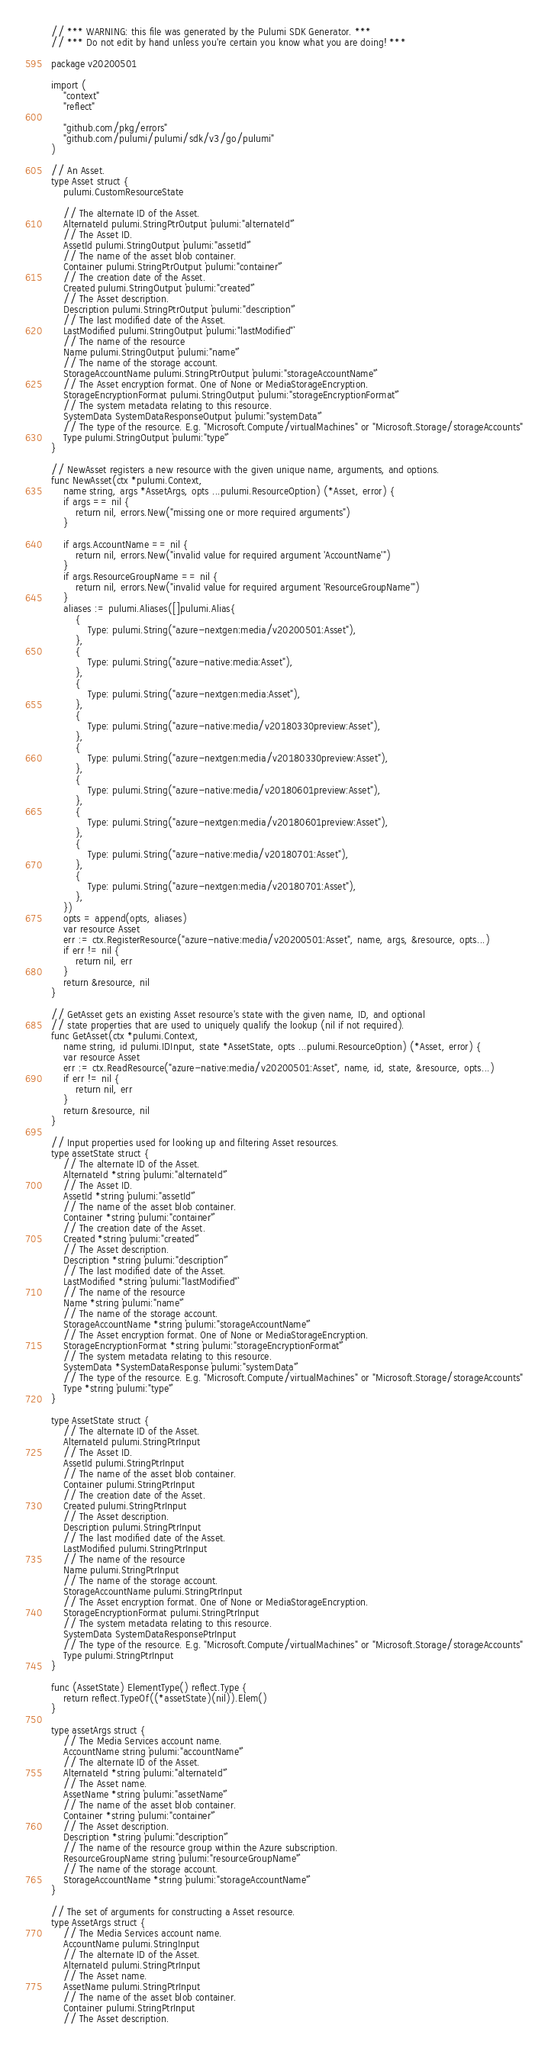Convert code to text. <code><loc_0><loc_0><loc_500><loc_500><_Go_>// *** WARNING: this file was generated by the Pulumi SDK Generator. ***
// *** Do not edit by hand unless you're certain you know what you are doing! ***

package v20200501

import (
	"context"
	"reflect"

	"github.com/pkg/errors"
	"github.com/pulumi/pulumi/sdk/v3/go/pulumi"
)

// An Asset.
type Asset struct {
	pulumi.CustomResourceState

	// The alternate ID of the Asset.
	AlternateId pulumi.StringPtrOutput `pulumi:"alternateId"`
	// The Asset ID.
	AssetId pulumi.StringOutput `pulumi:"assetId"`
	// The name of the asset blob container.
	Container pulumi.StringPtrOutput `pulumi:"container"`
	// The creation date of the Asset.
	Created pulumi.StringOutput `pulumi:"created"`
	// The Asset description.
	Description pulumi.StringPtrOutput `pulumi:"description"`
	// The last modified date of the Asset.
	LastModified pulumi.StringOutput `pulumi:"lastModified"`
	// The name of the resource
	Name pulumi.StringOutput `pulumi:"name"`
	// The name of the storage account.
	StorageAccountName pulumi.StringPtrOutput `pulumi:"storageAccountName"`
	// The Asset encryption format. One of None or MediaStorageEncryption.
	StorageEncryptionFormat pulumi.StringOutput `pulumi:"storageEncryptionFormat"`
	// The system metadata relating to this resource.
	SystemData SystemDataResponseOutput `pulumi:"systemData"`
	// The type of the resource. E.g. "Microsoft.Compute/virtualMachines" or "Microsoft.Storage/storageAccounts"
	Type pulumi.StringOutput `pulumi:"type"`
}

// NewAsset registers a new resource with the given unique name, arguments, and options.
func NewAsset(ctx *pulumi.Context,
	name string, args *AssetArgs, opts ...pulumi.ResourceOption) (*Asset, error) {
	if args == nil {
		return nil, errors.New("missing one or more required arguments")
	}

	if args.AccountName == nil {
		return nil, errors.New("invalid value for required argument 'AccountName'")
	}
	if args.ResourceGroupName == nil {
		return nil, errors.New("invalid value for required argument 'ResourceGroupName'")
	}
	aliases := pulumi.Aliases([]pulumi.Alias{
		{
			Type: pulumi.String("azure-nextgen:media/v20200501:Asset"),
		},
		{
			Type: pulumi.String("azure-native:media:Asset"),
		},
		{
			Type: pulumi.String("azure-nextgen:media:Asset"),
		},
		{
			Type: pulumi.String("azure-native:media/v20180330preview:Asset"),
		},
		{
			Type: pulumi.String("azure-nextgen:media/v20180330preview:Asset"),
		},
		{
			Type: pulumi.String("azure-native:media/v20180601preview:Asset"),
		},
		{
			Type: pulumi.String("azure-nextgen:media/v20180601preview:Asset"),
		},
		{
			Type: pulumi.String("azure-native:media/v20180701:Asset"),
		},
		{
			Type: pulumi.String("azure-nextgen:media/v20180701:Asset"),
		},
	})
	opts = append(opts, aliases)
	var resource Asset
	err := ctx.RegisterResource("azure-native:media/v20200501:Asset", name, args, &resource, opts...)
	if err != nil {
		return nil, err
	}
	return &resource, nil
}

// GetAsset gets an existing Asset resource's state with the given name, ID, and optional
// state properties that are used to uniquely qualify the lookup (nil if not required).
func GetAsset(ctx *pulumi.Context,
	name string, id pulumi.IDInput, state *AssetState, opts ...pulumi.ResourceOption) (*Asset, error) {
	var resource Asset
	err := ctx.ReadResource("azure-native:media/v20200501:Asset", name, id, state, &resource, opts...)
	if err != nil {
		return nil, err
	}
	return &resource, nil
}

// Input properties used for looking up and filtering Asset resources.
type assetState struct {
	// The alternate ID of the Asset.
	AlternateId *string `pulumi:"alternateId"`
	// The Asset ID.
	AssetId *string `pulumi:"assetId"`
	// The name of the asset blob container.
	Container *string `pulumi:"container"`
	// The creation date of the Asset.
	Created *string `pulumi:"created"`
	// The Asset description.
	Description *string `pulumi:"description"`
	// The last modified date of the Asset.
	LastModified *string `pulumi:"lastModified"`
	// The name of the resource
	Name *string `pulumi:"name"`
	// The name of the storage account.
	StorageAccountName *string `pulumi:"storageAccountName"`
	// The Asset encryption format. One of None or MediaStorageEncryption.
	StorageEncryptionFormat *string `pulumi:"storageEncryptionFormat"`
	// The system metadata relating to this resource.
	SystemData *SystemDataResponse `pulumi:"systemData"`
	// The type of the resource. E.g. "Microsoft.Compute/virtualMachines" or "Microsoft.Storage/storageAccounts"
	Type *string `pulumi:"type"`
}

type AssetState struct {
	// The alternate ID of the Asset.
	AlternateId pulumi.StringPtrInput
	// The Asset ID.
	AssetId pulumi.StringPtrInput
	// The name of the asset blob container.
	Container pulumi.StringPtrInput
	// The creation date of the Asset.
	Created pulumi.StringPtrInput
	// The Asset description.
	Description pulumi.StringPtrInput
	// The last modified date of the Asset.
	LastModified pulumi.StringPtrInput
	// The name of the resource
	Name pulumi.StringPtrInput
	// The name of the storage account.
	StorageAccountName pulumi.StringPtrInput
	// The Asset encryption format. One of None or MediaStorageEncryption.
	StorageEncryptionFormat pulumi.StringPtrInput
	// The system metadata relating to this resource.
	SystemData SystemDataResponsePtrInput
	// The type of the resource. E.g. "Microsoft.Compute/virtualMachines" or "Microsoft.Storage/storageAccounts"
	Type pulumi.StringPtrInput
}

func (AssetState) ElementType() reflect.Type {
	return reflect.TypeOf((*assetState)(nil)).Elem()
}

type assetArgs struct {
	// The Media Services account name.
	AccountName string `pulumi:"accountName"`
	// The alternate ID of the Asset.
	AlternateId *string `pulumi:"alternateId"`
	// The Asset name.
	AssetName *string `pulumi:"assetName"`
	// The name of the asset blob container.
	Container *string `pulumi:"container"`
	// The Asset description.
	Description *string `pulumi:"description"`
	// The name of the resource group within the Azure subscription.
	ResourceGroupName string `pulumi:"resourceGroupName"`
	// The name of the storage account.
	StorageAccountName *string `pulumi:"storageAccountName"`
}

// The set of arguments for constructing a Asset resource.
type AssetArgs struct {
	// The Media Services account name.
	AccountName pulumi.StringInput
	// The alternate ID of the Asset.
	AlternateId pulumi.StringPtrInput
	// The Asset name.
	AssetName pulumi.StringPtrInput
	// The name of the asset blob container.
	Container pulumi.StringPtrInput
	// The Asset description.</code> 